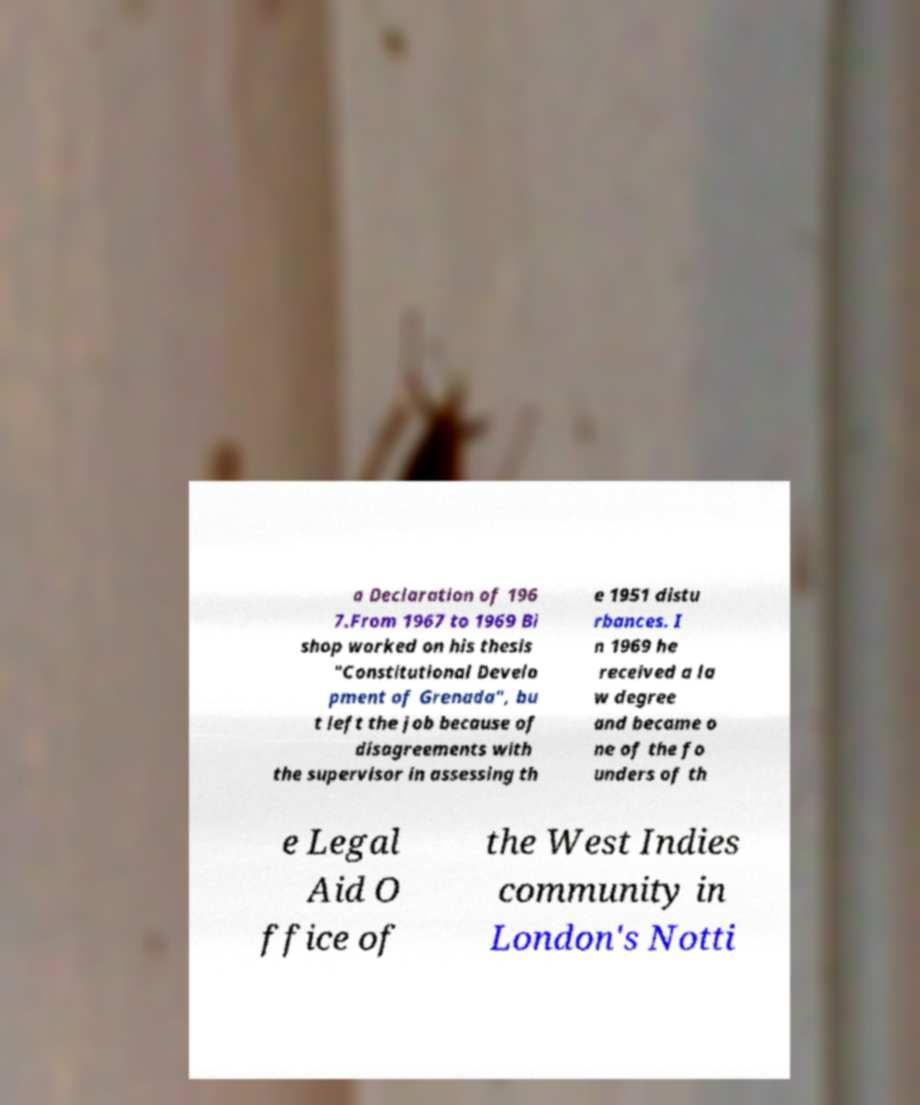What messages or text are displayed in this image? I need them in a readable, typed format. a Declaration of 196 7.From 1967 to 1969 Bi shop worked on his thesis "Constitutional Develo pment of Grenada", bu t left the job because of disagreements with the supervisor in assessing th e 1951 distu rbances. I n 1969 he received a la w degree and became o ne of the fo unders of th e Legal Aid O ffice of the West Indies community in London's Notti 